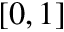Convert formula to latex. <formula><loc_0><loc_0><loc_500><loc_500>[ 0 , 1 ]</formula> 